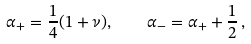Convert formula to latex. <formula><loc_0><loc_0><loc_500><loc_500>\alpha _ { + } = \frac { 1 } { 4 } ( 1 + \nu ) , \quad \alpha _ { - } = \alpha _ { + } + \frac { 1 } { 2 } \, ,</formula> 